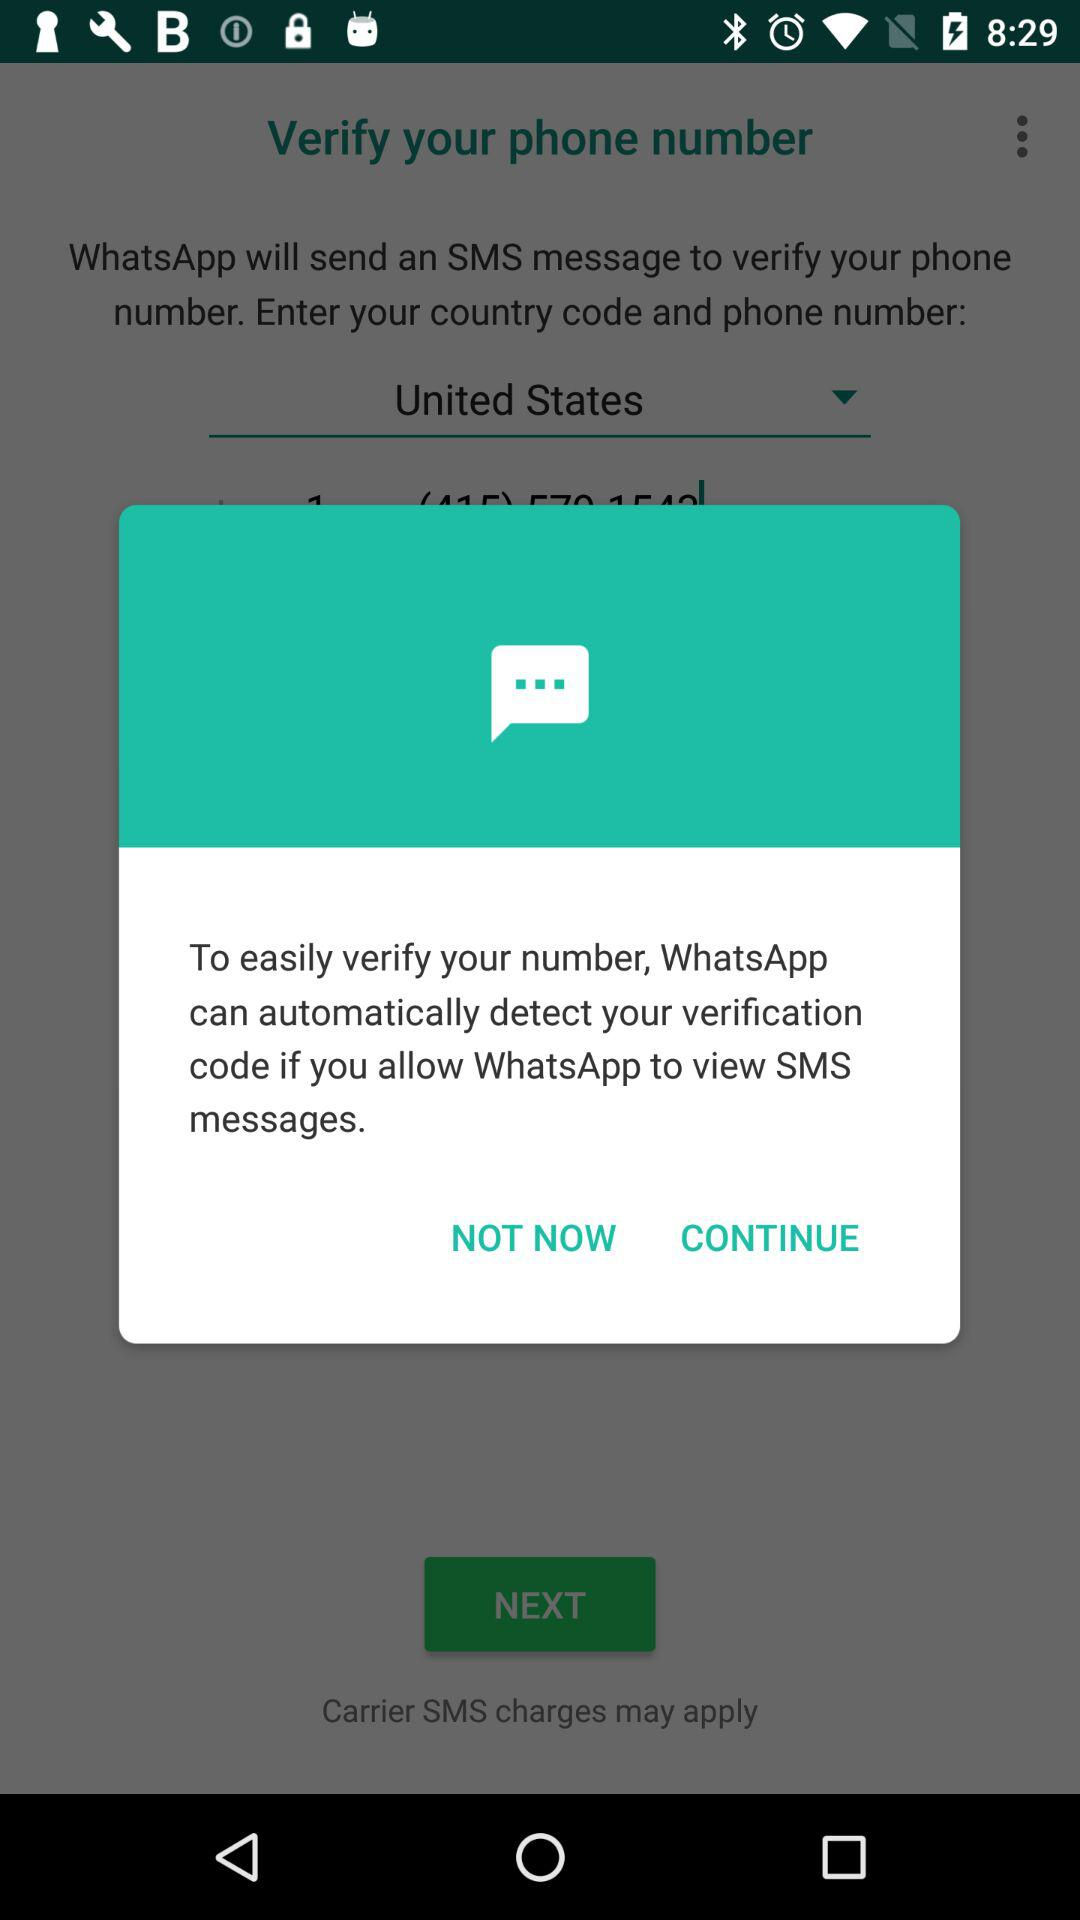Which country has been selected? The country that has been selected is the United States. 